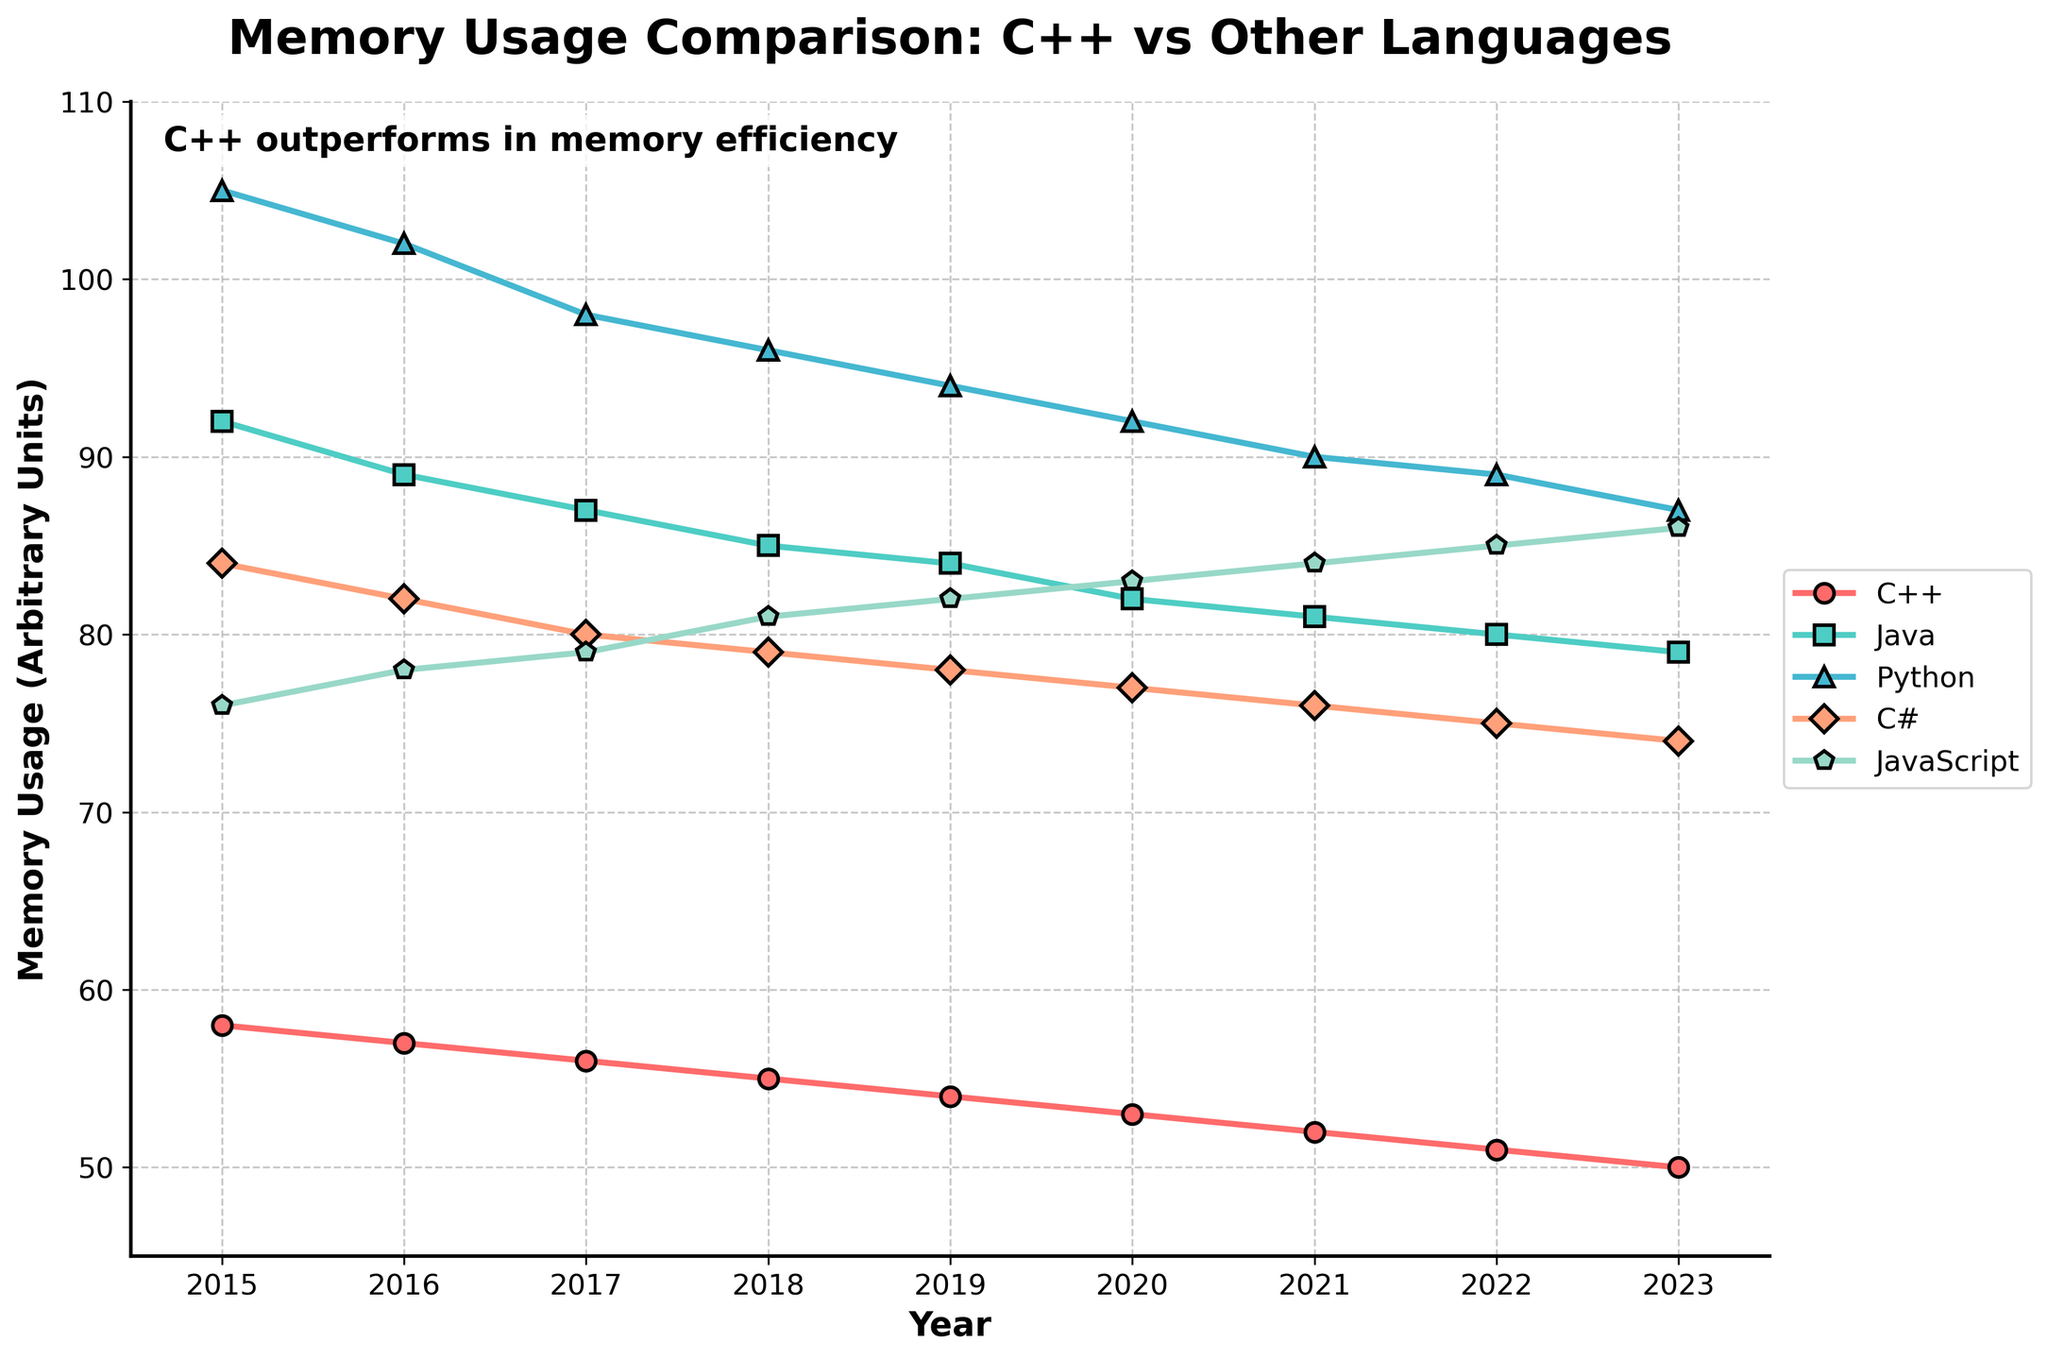What trend is observed in C++ memory usage from 2015 to 2023? The line representing C++ shows a consistent downward trend from 58 units in 2015 to 50 units in 2023.
Answer: Decreasing trend Which language shows the highest memory usage in 2023? By inspecting the rightmost points of the lines in the chart for 2023, JavaScript has the highest memory usage at 86 units.
Answer: JavaScript How many units less memory does C++ use compared to Python in 2020? The memory usage for C++ in 2020 is 53 units and for Python is 92 units. The difference is 92 - 53 = 39 units.
Answer: 39 units Between which years does Java show the most significant drop in memory usage? By comparing the slopes of the line segments for Java, the steepest decline is between 2015 and 2016, where memory usage drops from 92 to 89 units.
Answer: 2015-2016 What is the average memory usage of C++ from 2015 to 2023? Add the memory usage for each year: 58 + 57 + 56 + 55 + 54 + 53 + 52 + 51 + 50 = 436. Then divide by the number of years, which is 9. The average is 436 / 9 ≈ 48.44 units.
Answer: 48.44 units During which year did Java and JavaScript have the same memory usage? Visually inspect the overlapping points of the lines representing Java and JavaScript, which occurred in 2019, where both show a memory usage of 84 units.
Answer: 2019 Which language, apart from C++, shows a generally decreasing trend in memory usage? By examining the chart, Java shows a generally declining trend from 92 units in 2015 to 79 units in 2023.
Answer: Java What is the overall change in memory usage for C# from 2015 to 2023? The memory usage for C# in 2015 is 84 units and in 2023 is 74 units. The change is 84 - 74 = 10 units decrease.
Answer: 10 units decrease Is there any year where the memory usage of C++ is equal to the usage of C#? By observing the chart, there is no year where the lines representing C++ and C# intersect, indicating their memory usages are never equal.
Answer: No 